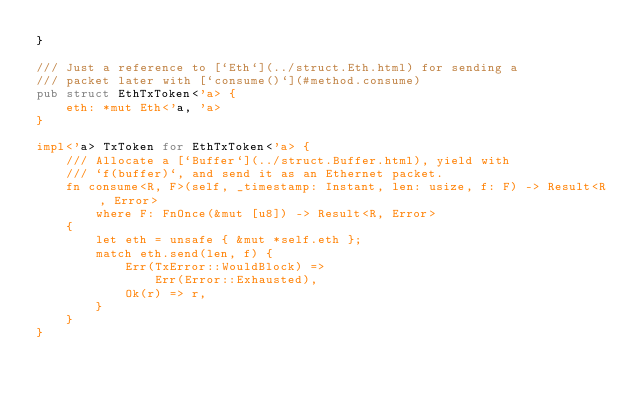<code> <loc_0><loc_0><loc_500><loc_500><_Rust_>}

/// Just a reference to [`Eth`](../struct.Eth.html) for sending a
/// packet later with [`consume()`](#method.consume)
pub struct EthTxToken<'a> {
    eth: *mut Eth<'a, 'a>
}

impl<'a> TxToken for EthTxToken<'a> {
    /// Allocate a [`Buffer`](../struct.Buffer.html), yield with
    /// `f(buffer)`, and send it as an Ethernet packet.
    fn consume<R, F>(self, _timestamp: Instant, len: usize, f: F) -> Result<R, Error>
        where F: FnOnce(&mut [u8]) -> Result<R, Error>
    {
        let eth = unsafe { &mut *self.eth };
        match eth.send(len, f) {
            Err(TxError::WouldBlock) =>
                Err(Error::Exhausted),
            Ok(r) => r,
        }
    }
}
</code> 